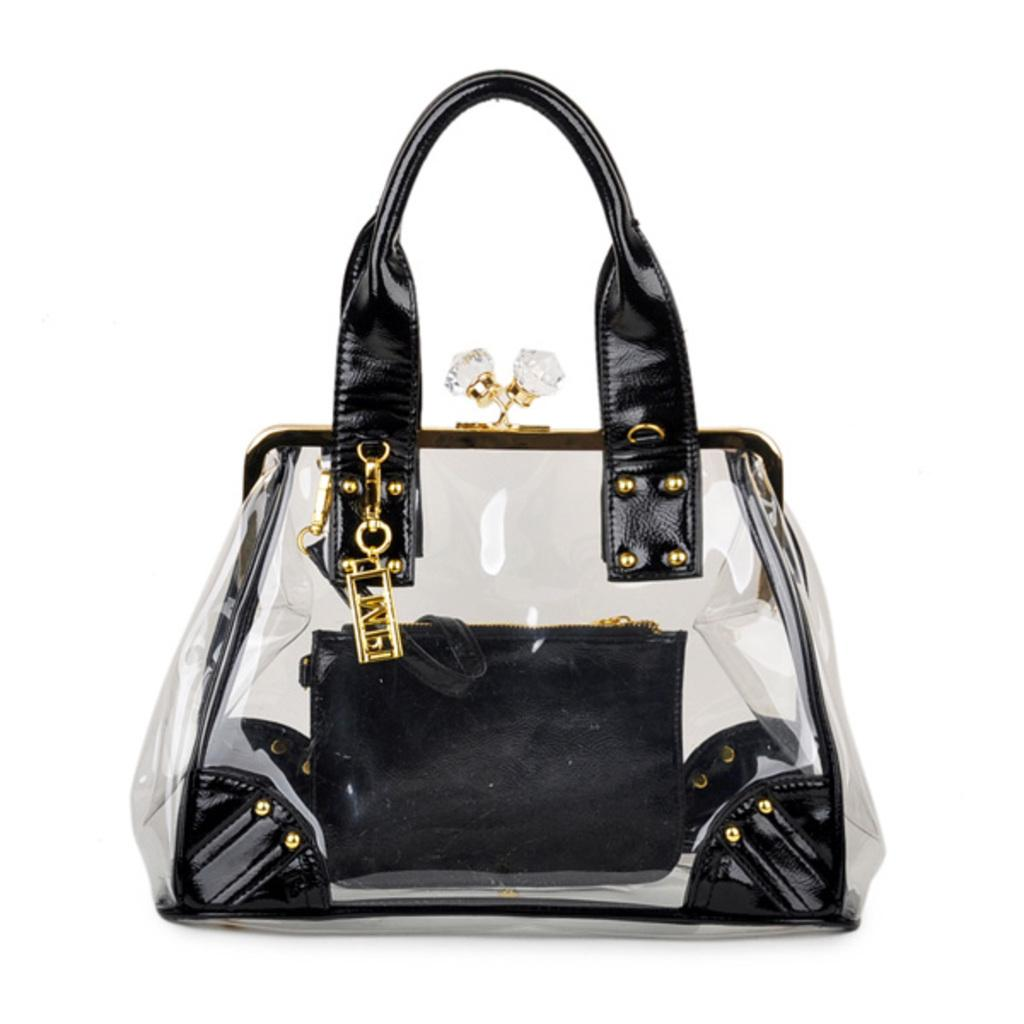What colors are used in the handbag in the image? The handbag is black and golden in color. What type of invention is being demonstrated in the image? There is no invention being demonstrated in the image; it only features a black and golden handbag. What type of food is being prepared in the image? There is no food preparation or consumption depicted in the image; it only features a black and golden handbag. 